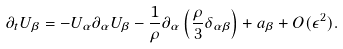<formula> <loc_0><loc_0><loc_500><loc_500>\partial _ { t } U _ { \beta } = - U _ { \alpha } \partial _ { \alpha } U _ { \beta } - \frac { 1 } { \rho } \partial _ { \alpha } \left ( \frac { \rho } { 3 } \delta _ { \alpha \beta } \right ) + a _ { \beta } + O ( \epsilon ^ { 2 } ) .</formula> 